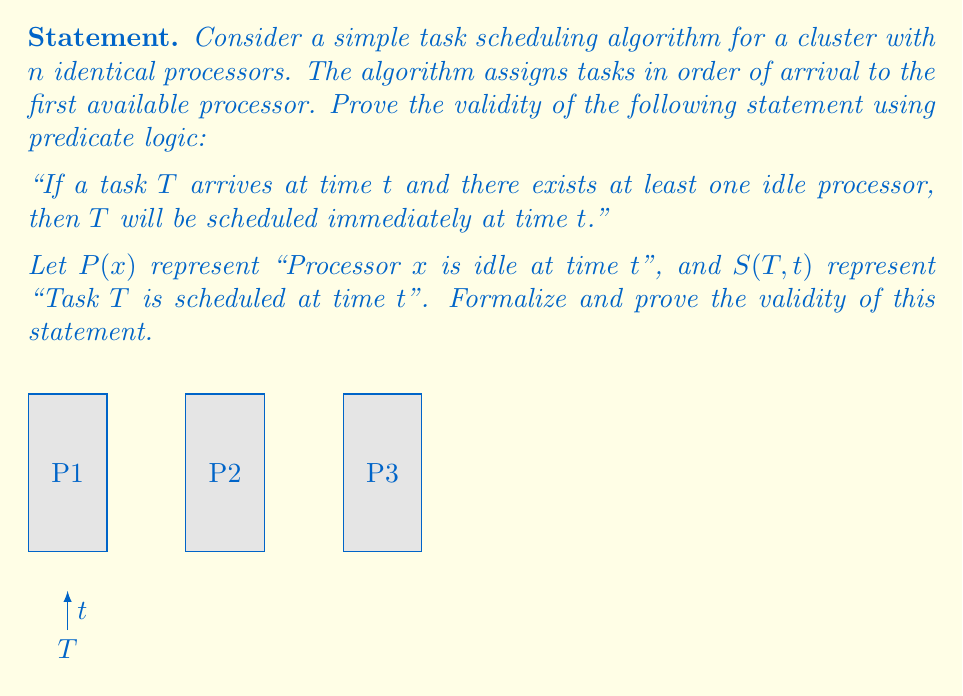Provide a solution to this math problem. To prove the validity of the statement using predicate logic, we'll follow these steps:

1) First, let's formalize the statement in predicate logic:

   $$(\exists x (P(x))) \rightarrow S(T,t)$$

   This reads as "If there exists an $x$ such that $P(x)$ is true (i.e., there exists an idle processor), then $S(T,t)$ is true (i.e., task $T$ is scheduled at time $t$)."

2) To prove the validity of this statement, we can use a proof by contradiction. Let's assume the statement is false and derive a contradiction.

3) If the statement is false, then its negation must be true. The negation is:

   $$(\exists x (P(x))) \wedge \neg S(T,t)$$

   This means "There exists an idle processor AND task $T$ is not scheduled at time $t$."

4) Let's consider the implications of this negation:
   - We know there's at least one idle processor at time $t$.
   - We also know that $T$ arrived at time $t$.
   - The scheduling algorithm assigns tasks to the first available processor.
   - Yet, $T$ is not scheduled at time $t$.

5) This leads to a contradiction because:
   - If there's an idle processor and a task has arrived, the algorithm must schedule the task immediately.
   - The negation states that this doesn't happen, which contradicts the definition of the algorithm.

6) Since assuming the negation leads to a contradiction, our original statement must be valid.

Therefore, we have proved the validity of the statement "If a task $T$ arrives at time $t$ and there exists at least one idle processor, then $T$ will be scheduled immediately at time $t$" using predicate logic and proof by contradiction.
Answer: The statement is valid. Proof by contradiction shows that assuming the negation leads to a logical inconsistency with the algorithm's definition. 